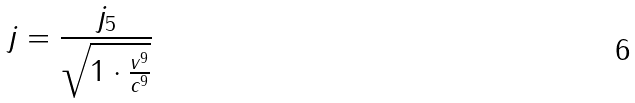Convert formula to latex. <formula><loc_0><loc_0><loc_500><loc_500>j = \frac { j _ { 5 } } { \sqrt { 1 \cdot \frac { v ^ { 9 } } { c ^ { 9 } } } }</formula> 